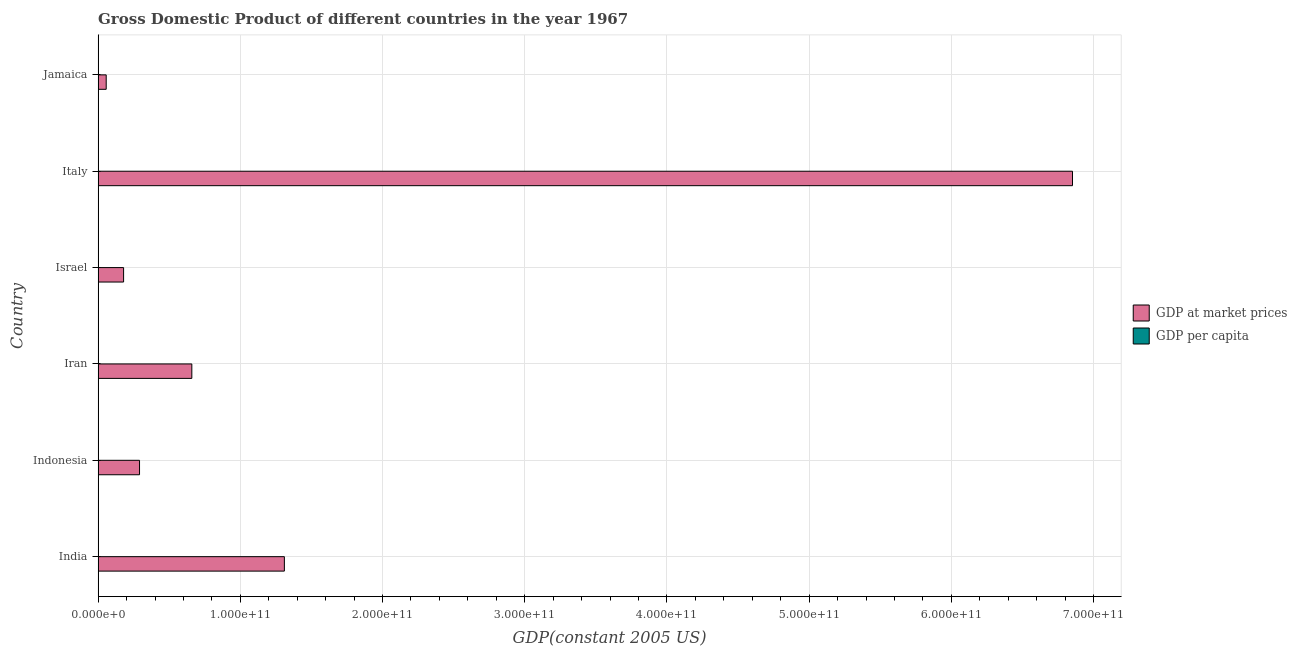How many different coloured bars are there?
Make the answer very short. 2. Are the number of bars on each tick of the Y-axis equal?
Offer a terse response. Yes. How many bars are there on the 5th tick from the top?
Offer a very short reply. 2. How many bars are there on the 5th tick from the bottom?
Give a very brief answer. 2. What is the gdp per capita in Italy?
Offer a very short reply. 1.30e+04. Across all countries, what is the maximum gdp per capita?
Your answer should be very brief. 1.30e+04. Across all countries, what is the minimum gdp per capita?
Provide a succinct answer. 252.29. In which country was the gdp per capita maximum?
Give a very brief answer. Italy. What is the total gdp per capita in the graph?
Your answer should be very brief. 2.57e+04. What is the difference between the gdp at market prices in Iran and that in Jamaica?
Keep it short and to the point. 6.02e+1. What is the difference between the gdp per capita in Israel and the gdp at market prices in India?
Give a very brief answer. -1.31e+11. What is the average gdp per capita per country?
Ensure brevity in your answer.  4277.77. What is the difference between the gdp per capita and gdp at market prices in India?
Offer a terse response. -1.31e+11. What is the ratio of the gdp at market prices in Indonesia to that in Jamaica?
Your response must be concise. 5.12. Is the difference between the gdp at market prices in Iran and Israel greater than the difference between the gdp per capita in Iran and Israel?
Offer a terse response. Yes. What is the difference between the highest and the second highest gdp at market prices?
Make the answer very short. 5.54e+11. What is the difference between the highest and the lowest gdp at market prices?
Keep it short and to the point. 6.80e+11. In how many countries, is the gdp at market prices greater than the average gdp at market prices taken over all countries?
Keep it short and to the point. 1. What does the 2nd bar from the top in Italy represents?
Offer a very short reply. GDP at market prices. What does the 1st bar from the bottom in Iran represents?
Give a very brief answer. GDP at market prices. How many bars are there?
Keep it short and to the point. 12. Are all the bars in the graph horizontal?
Keep it short and to the point. Yes. What is the difference between two consecutive major ticks on the X-axis?
Your answer should be compact. 1.00e+11. Where does the legend appear in the graph?
Your answer should be compact. Center right. How many legend labels are there?
Offer a terse response. 2. What is the title of the graph?
Give a very brief answer. Gross Domestic Product of different countries in the year 1967. Does "Lower secondary rate" appear as one of the legend labels in the graph?
Your response must be concise. No. What is the label or title of the X-axis?
Ensure brevity in your answer.  GDP(constant 2005 US). What is the GDP(constant 2005 US) of GDP at market prices in India?
Your answer should be very brief. 1.31e+11. What is the GDP(constant 2005 US) in GDP per capita in India?
Your response must be concise. 252.29. What is the GDP(constant 2005 US) of GDP at market prices in Indonesia?
Keep it short and to the point. 2.91e+1. What is the GDP(constant 2005 US) in GDP per capita in Indonesia?
Give a very brief answer. 274.99. What is the GDP(constant 2005 US) of GDP at market prices in Iran?
Provide a succinct answer. 6.59e+1. What is the GDP(constant 2005 US) in GDP per capita in Iran?
Ensure brevity in your answer.  2503.85. What is the GDP(constant 2005 US) in GDP at market prices in Israel?
Your response must be concise. 1.79e+1. What is the GDP(constant 2005 US) in GDP per capita in Israel?
Keep it short and to the point. 6527.65. What is the GDP(constant 2005 US) of GDP at market prices in Italy?
Your response must be concise. 6.85e+11. What is the GDP(constant 2005 US) of GDP per capita in Italy?
Make the answer very short. 1.30e+04. What is the GDP(constant 2005 US) of GDP at market prices in Jamaica?
Your response must be concise. 5.69e+09. What is the GDP(constant 2005 US) of GDP per capita in Jamaica?
Offer a terse response. 3154.93. Across all countries, what is the maximum GDP(constant 2005 US) in GDP at market prices?
Your answer should be very brief. 6.85e+11. Across all countries, what is the maximum GDP(constant 2005 US) of GDP per capita?
Offer a very short reply. 1.30e+04. Across all countries, what is the minimum GDP(constant 2005 US) in GDP at market prices?
Ensure brevity in your answer.  5.69e+09. Across all countries, what is the minimum GDP(constant 2005 US) of GDP per capita?
Offer a very short reply. 252.29. What is the total GDP(constant 2005 US) in GDP at market prices in the graph?
Keep it short and to the point. 9.35e+11. What is the total GDP(constant 2005 US) in GDP per capita in the graph?
Your answer should be very brief. 2.57e+04. What is the difference between the GDP(constant 2005 US) of GDP at market prices in India and that in Indonesia?
Make the answer very short. 1.02e+11. What is the difference between the GDP(constant 2005 US) in GDP per capita in India and that in Indonesia?
Your answer should be very brief. -22.7. What is the difference between the GDP(constant 2005 US) in GDP at market prices in India and that in Iran?
Your response must be concise. 6.51e+1. What is the difference between the GDP(constant 2005 US) of GDP per capita in India and that in Iran?
Your response must be concise. -2251.56. What is the difference between the GDP(constant 2005 US) in GDP at market prices in India and that in Israel?
Offer a very short reply. 1.13e+11. What is the difference between the GDP(constant 2005 US) of GDP per capita in India and that in Israel?
Ensure brevity in your answer.  -6275.36. What is the difference between the GDP(constant 2005 US) in GDP at market prices in India and that in Italy?
Offer a very short reply. -5.54e+11. What is the difference between the GDP(constant 2005 US) in GDP per capita in India and that in Italy?
Give a very brief answer. -1.27e+04. What is the difference between the GDP(constant 2005 US) of GDP at market prices in India and that in Jamaica?
Your answer should be very brief. 1.25e+11. What is the difference between the GDP(constant 2005 US) of GDP per capita in India and that in Jamaica?
Ensure brevity in your answer.  -2902.64. What is the difference between the GDP(constant 2005 US) of GDP at market prices in Indonesia and that in Iran?
Your response must be concise. -3.68e+1. What is the difference between the GDP(constant 2005 US) in GDP per capita in Indonesia and that in Iran?
Offer a very short reply. -2228.86. What is the difference between the GDP(constant 2005 US) of GDP at market prices in Indonesia and that in Israel?
Your answer should be compact. 1.12e+1. What is the difference between the GDP(constant 2005 US) of GDP per capita in Indonesia and that in Israel?
Give a very brief answer. -6252.66. What is the difference between the GDP(constant 2005 US) of GDP at market prices in Indonesia and that in Italy?
Offer a very short reply. -6.56e+11. What is the difference between the GDP(constant 2005 US) of GDP per capita in Indonesia and that in Italy?
Keep it short and to the point. -1.27e+04. What is the difference between the GDP(constant 2005 US) of GDP at market prices in Indonesia and that in Jamaica?
Offer a very short reply. 2.34e+1. What is the difference between the GDP(constant 2005 US) of GDP per capita in Indonesia and that in Jamaica?
Give a very brief answer. -2879.94. What is the difference between the GDP(constant 2005 US) of GDP at market prices in Iran and that in Israel?
Make the answer very short. 4.80e+1. What is the difference between the GDP(constant 2005 US) in GDP per capita in Iran and that in Israel?
Make the answer very short. -4023.8. What is the difference between the GDP(constant 2005 US) of GDP at market prices in Iran and that in Italy?
Make the answer very short. -6.19e+11. What is the difference between the GDP(constant 2005 US) of GDP per capita in Iran and that in Italy?
Make the answer very short. -1.04e+04. What is the difference between the GDP(constant 2005 US) of GDP at market prices in Iran and that in Jamaica?
Ensure brevity in your answer.  6.02e+1. What is the difference between the GDP(constant 2005 US) in GDP per capita in Iran and that in Jamaica?
Provide a succinct answer. -651.08. What is the difference between the GDP(constant 2005 US) in GDP at market prices in Israel and that in Italy?
Provide a short and direct response. -6.67e+11. What is the difference between the GDP(constant 2005 US) of GDP per capita in Israel and that in Italy?
Ensure brevity in your answer.  -6425.28. What is the difference between the GDP(constant 2005 US) of GDP at market prices in Israel and that in Jamaica?
Provide a succinct answer. 1.22e+1. What is the difference between the GDP(constant 2005 US) in GDP per capita in Israel and that in Jamaica?
Offer a terse response. 3372.72. What is the difference between the GDP(constant 2005 US) in GDP at market prices in Italy and that in Jamaica?
Provide a short and direct response. 6.80e+11. What is the difference between the GDP(constant 2005 US) in GDP per capita in Italy and that in Jamaica?
Give a very brief answer. 9798. What is the difference between the GDP(constant 2005 US) in GDP at market prices in India and the GDP(constant 2005 US) in GDP per capita in Indonesia?
Keep it short and to the point. 1.31e+11. What is the difference between the GDP(constant 2005 US) of GDP at market prices in India and the GDP(constant 2005 US) of GDP per capita in Iran?
Your answer should be compact. 1.31e+11. What is the difference between the GDP(constant 2005 US) of GDP at market prices in India and the GDP(constant 2005 US) of GDP per capita in Israel?
Ensure brevity in your answer.  1.31e+11. What is the difference between the GDP(constant 2005 US) in GDP at market prices in India and the GDP(constant 2005 US) in GDP per capita in Italy?
Your response must be concise. 1.31e+11. What is the difference between the GDP(constant 2005 US) of GDP at market prices in India and the GDP(constant 2005 US) of GDP per capita in Jamaica?
Ensure brevity in your answer.  1.31e+11. What is the difference between the GDP(constant 2005 US) in GDP at market prices in Indonesia and the GDP(constant 2005 US) in GDP per capita in Iran?
Keep it short and to the point. 2.91e+1. What is the difference between the GDP(constant 2005 US) in GDP at market prices in Indonesia and the GDP(constant 2005 US) in GDP per capita in Israel?
Provide a short and direct response. 2.91e+1. What is the difference between the GDP(constant 2005 US) of GDP at market prices in Indonesia and the GDP(constant 2005 US) of GDP per capita in Italy?
Your answer should be very brief. 2.91e+1. What is the difference between the GDP(constant 2005 US) in GDP at market prices in Indonesia and the GDP(constant 2005 US) in GDP per capita in Jamaica?
Offer a terse response. 2.91e+1. What is the difference between the GDP(constant 2005 US) of GDP at market prices in Iran and the GDP(constant 2005 US) of GDP per capita in Israel?
Make the answer very short. 6.59e+1. What is the difference between the GDP(constant 2005 US) of GDP at market prices in Iran and the GDP(constant 2005 US) of GDP per capita in Italy?
Give a very brief answer. 6.59e+1. What is the difference between the GDP(constant 2005 US) of GDP at market prices in Iran and the GDP(constant 2005 US) of GDP per capita in Jamaica?
Provide a succinct answer. 6.59e+1. What is the difference between the GDP(constant 2005 US) of GDP at market prices in Israel and the GDP(constant 2005 US) of GDP per capita in Italy?
Your response must be concise. 1.79e+1. What is the difference between the GDP(constant 2005 US) in GDP at market prices in Israel and the GDP(constant 2005 US) in GDP per capita in Jamaica?
Offer a very short reply. 1.79e+1. What is the difference between the GDP(constant 2005 US) of GDP at market prices in Italy and the GDP(constant 2005 US) of GDP per capita in Jamaica?
Keep it short and to the point. 6.85e+11. What is the average GDP(constant 2005 US) in GDP at market prices per country?
Your response must be concise. 1.56e+11. What is the average GDP(constant 2005 US) of GDP per capita per country?
Make the answer very short. 4277.78. What is the difference between the GDP(constant 2005 US) in GDP at market prices and GDP(constant 2005 US) in GDP per capita in India?
Ensure brevity in your answer.  1.31e+11. What is the difference between the GDP(constant 2005 US) in GDP at market prices and GDP(constant 2005 US) in GDP per capita in Indonesia?
Give a very brief answer. 2.91e+1. What is the difference between the GDP(constant 2005 US) of GDP at market prices and GDP(constant 2005 US) of GDP per capita in Iran?
Offer a very short reply. 6.59e+1. What is the difference between the GDP(constant 2005 US) of GDP at market prices and GDP(constant 2005 US) of GDP per capita in Israel?
Offer a very short reply. 1.79e+1. What is the difference between the GDP(constant 2005 US) of GDP at market prices and GDP(constant 2005 US) of GDP per capita in Italy?
Offer a terse response. 6.85e+11. What is the difference between the GDP(constant 2005 US) of GDP at market prices and GDP(constant 2005 US) of GDP per capita in Jamaica?
Your response must be concise. 5.69e+09. What is the ratio of the GDP(constant 2005 US) of GDP at market prices in India to that in Indonesia?
Offer a very short reply. 4.5. What is the ratio of the GDP(constant 2005 US) of GDP per capita in India to that in Indonesia?
Provide a short and direct response. 0.92. What is the ratio of the GDP(constant 2005 US) in GDP at market prices in India to that in Iran?
Your answer should be compact. 1.99. What is the ratio of the GDP(constant 2005 US) of GDP per capita in India to that in Iran?
Your answer should be very brief. 0.1. What is the ratio of the GDP(constant 2005 US) of GDP at market prices in India to that in Israel?
Provide a succinct answer. 7.31. What is the ratio of the GDP(constant 2005 US) of GDP per capita in India to that in Israel?
Give a very brief answer. 0.04. What is the ratio of the GDP(constant 2005 US) of GDP at market prices in India to that in Italy?
Keep it short and to the point. 0.19. What is the ratio of the GDP(constant 2005 US) in GDP per capita in India to that in Italy?
Make the answer very short. 0.02. What is the ratio of the GDP(constant 2005 US) in GDP at market prices in India to that in Jamaica?
Your answer should be compact. 23.01. What is the ratio of the GDP(constant 2005 US) of GDP at market prices in Indonesia to that in Iran?
Offer a terse response. 0.44. What is the ratio of the GDP(constant 2005 US) of GDP per capita in Indonesia to that in Iran?
Give a very brief answer. 0.11. What is the ratio of the GDP(constant 2005 US) in GDP at market prices in Indonesia to that in Israel?
Your response must be concise. 1.63. What is the ratio of the GDP(constant 2005 US) in GDP per capita in Indonesia to that in Israel?
Your answer should be very brief. 0.04. What is the ratio of the GDP(constant 2005 US) in GDP at market prices in Indonesia to that in Italy?
Offer a terse response. 0.04. What is the ratio of the GDP(constant 2005 US) in GDP per capita in Indonesia to that in Italy?
Give a very brief answer. 0.02. What is the ratio of the GDP(constant 2005 US) in GDP at market prices in Indonesia to that in Jamaica?
Your response must be concise. 5.12. What is the ratio of the GDP(constant 2005 US) of GDP per capita in Indonesia to that in Jamaica?
Keep it short and to the point. 0.09. What is the ratio of the GDP(constant 2005 US) of GDP at market prices in Iran to that in Israel?
Your response must be concise. 3.68. What is the ratio of the GDP(constant 2005 US) in GDP per capita in Iran to that in Israel?
Your answer should be very brief. 0.38. What is the ratio of the GDP(constant 2005 US) of GDP at market prices in Iran to that in Italy?
Your answer should be compact. 0.1. What is the ratio of the GDP(constant 2005 US) of GDP per capita in Iran to that in Italy?
Give a very brief answer. 0.19. What is the ratio of the GDP(constant 2005 US) in GDP at market prices in Iran to that in Jamaica?
Make the answer very short. 11.58. What is the ratio of the GDP(constant 2005 US) of GDP per capita in Iran to that in Jamaica?
Your answer should be very brief. 0.79. What is the ratio of the GDP(constant 2005 US) in GDP at market prices in Israel to that in Italy?
Keep it short and to the point. 0.03. What is the ratio of the GDP(constant 2005 US) of GDP per capita in Israel to that in Italy?
Keep it short and to the point. 0.5. What is the ratio of the GDP(constant 2005 US) in GDP at market prices in Israel to that in Jamaica?
Your answer should be compact. 3.15. What is the ratio of the GDP(constant 2005 US) of GDP per capita in Israel to that in Jamaica?
Your answer should be compact. 2.07. What is the ratio of the GDP(constant 2005 US) in GDP at market prices in Italy to that in Jamaica?
Your answer should be compact. 120.4. What is the ratio of the GDP(constant 2005 US) in GDP per capita in Italy to that in Jamaica?
Keep it short and to the point. 4.11. What is the difference between the highest and the second highest GDP(constant 2005 US) in GDP at market prices?
Offer a very short reply. 5.54e+11. What is the difference between the highest and the second highest GDP(constant 2005 US) of GDP per capita?
Your response must be concise. 6425.28. What is the difference between the highest and the lowest GDP(constant 2005 US) of GDP at market prices?
Make the answer very short. 6.80e+11. What is the difference between the highest and the lowest GDP(constant 2005 US) in GDP per capita?
Offer a terse response. 1.27e+04. 